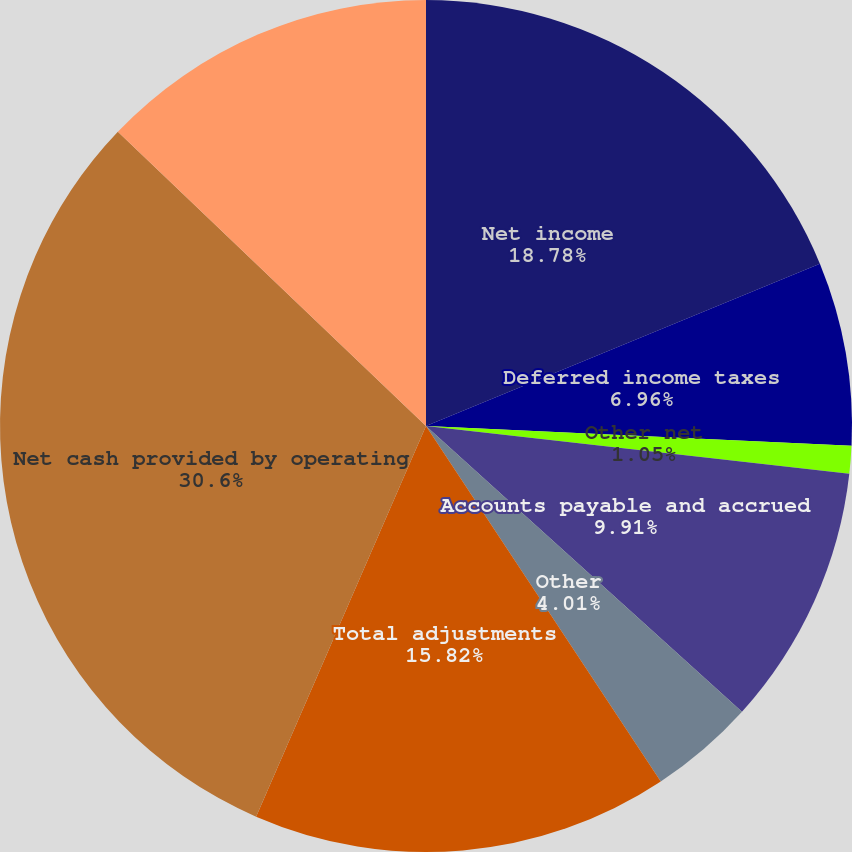<chart> <loc_0><loc_0><loc_500><loc_500><pie_chart><fcel>Net income<fcel>Deferred income taxes<fcel>Other net<fcel>Accounts payable and accrued<fcel>Other<fcel>Total adjustments<fcel>Net cash provided by operating<fcel>Net cash used by investing<nl><fcel>18.78%<fcel>6.96%<fcel>1.05%<fcel>9.91%<fcel>4.01%<fcel>15.82%<fcel>30.6%<fcel>12.87%<nl></chart> 